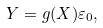<formula> <loc_0><loc_0><loc_500><loc_500>Y = g ( X ) \varepsilon _ { 0 } ,</formula> 